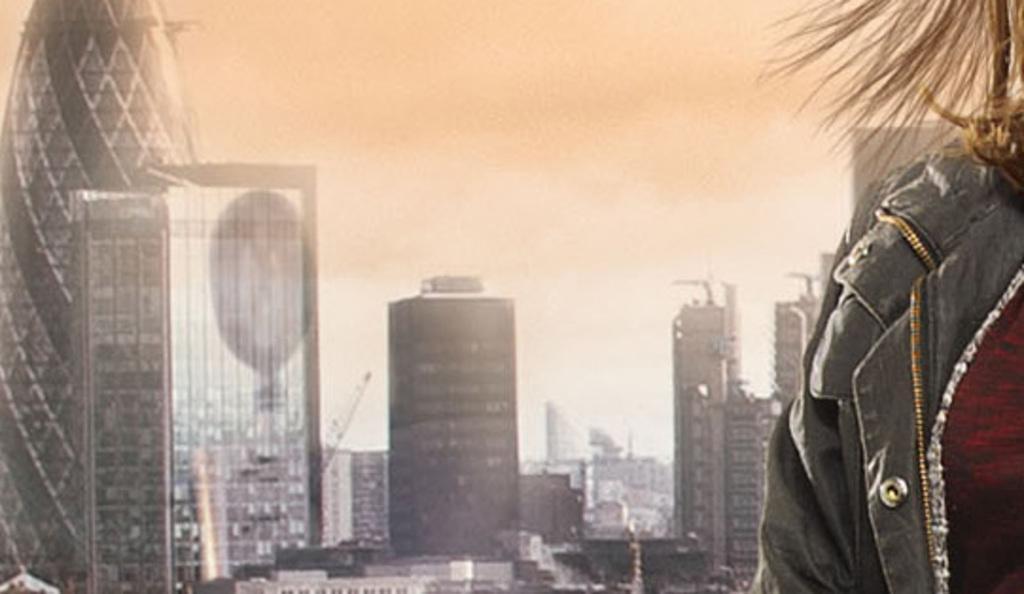How would you summarize this image in a sentence or two? In this image I can see few buildings, in front I can see a person wearing black color jacket and I can see sky in white color. 